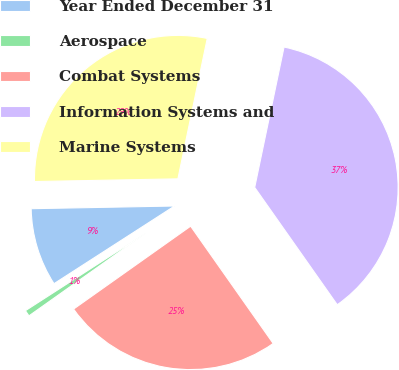Convert chart. <chart><loc_0><loc_0><loc_500><loc_500><pie_chart><fcel>Year Ended December 31<fcel>Aerospace<fcel>Combat Systems<fcel>Information Systems and<fcel>Marine Systems<nl><fcel>8.81%<fcel>0.7%<fcel>24.95%<fcel>36.96%<fcel>28.58%<nl></chart> 